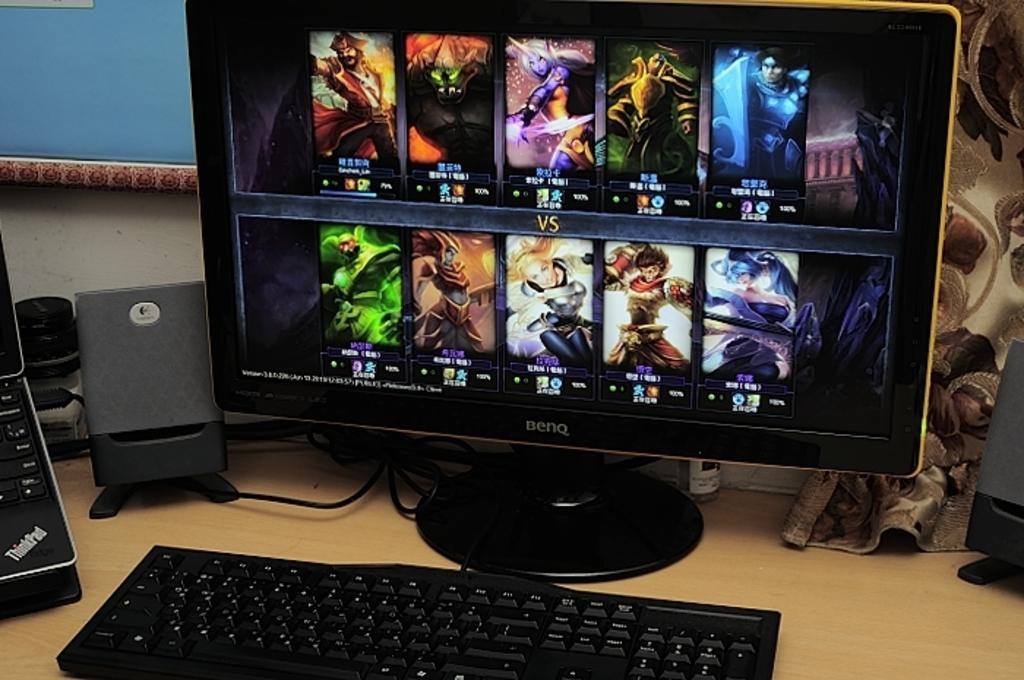<image>
Summarize the visual content of the image. A brand name BENQ computer monitor sitting on a wooden table with a keyboard and speakers. 